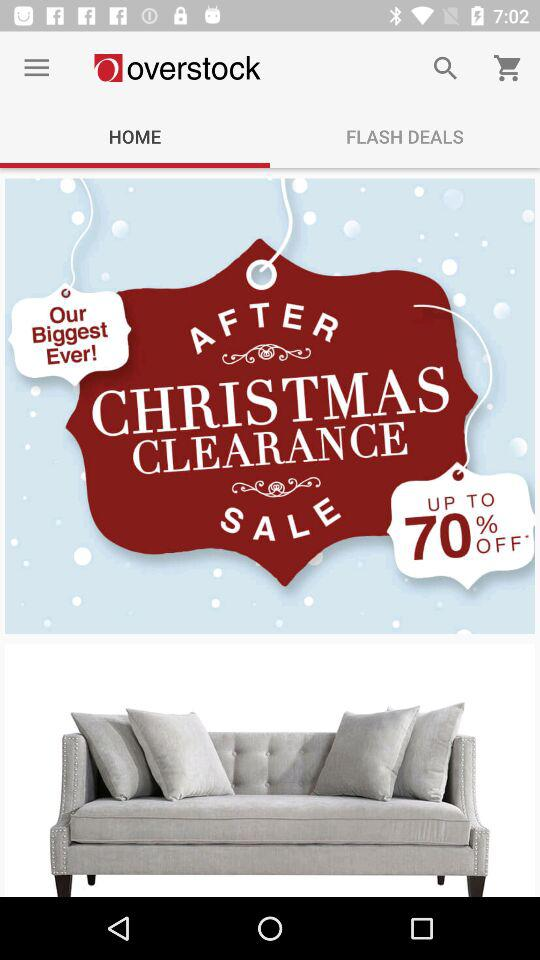Which tab is selected in the Overstock menu? The selected tab is "HOME". 